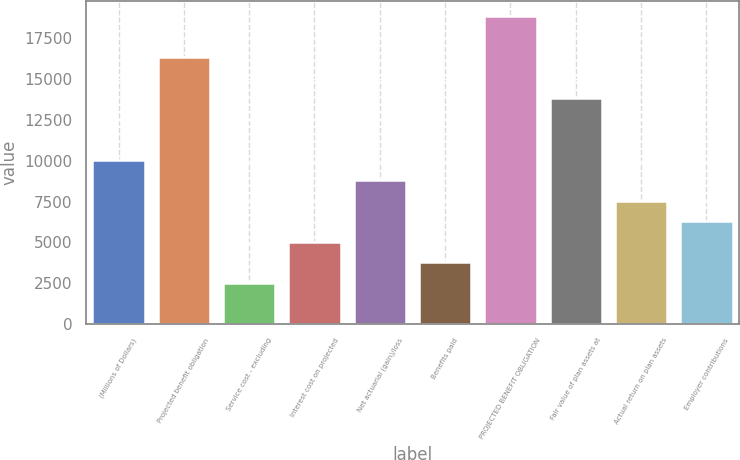<chart> <loc_0><loc_0><loc_500><loc_500><bar_chart><fcel>(Millions of Dollars)<fcel>Projected benefit obligation<fcel>Service cost - excluding<fcel>Interest cost on projected<fcel>Net actuarial (gain)/loss<fcel>Benefits paid<fcel>PROJECTED BENEFIT OBLIGATION<fcel>Fair value of plan assets at<fcel>Actual return on plan assets<fcel>Employer contributions<nl><fcel>10059.6<fcel>16340.6<fcel>2522.4<fcel>5034.8<fcel>8803.4<fcel>3778.6<fcel>18853<fcel>13828.2<fcel>7547.2<fcel>6291<nl></chart> 